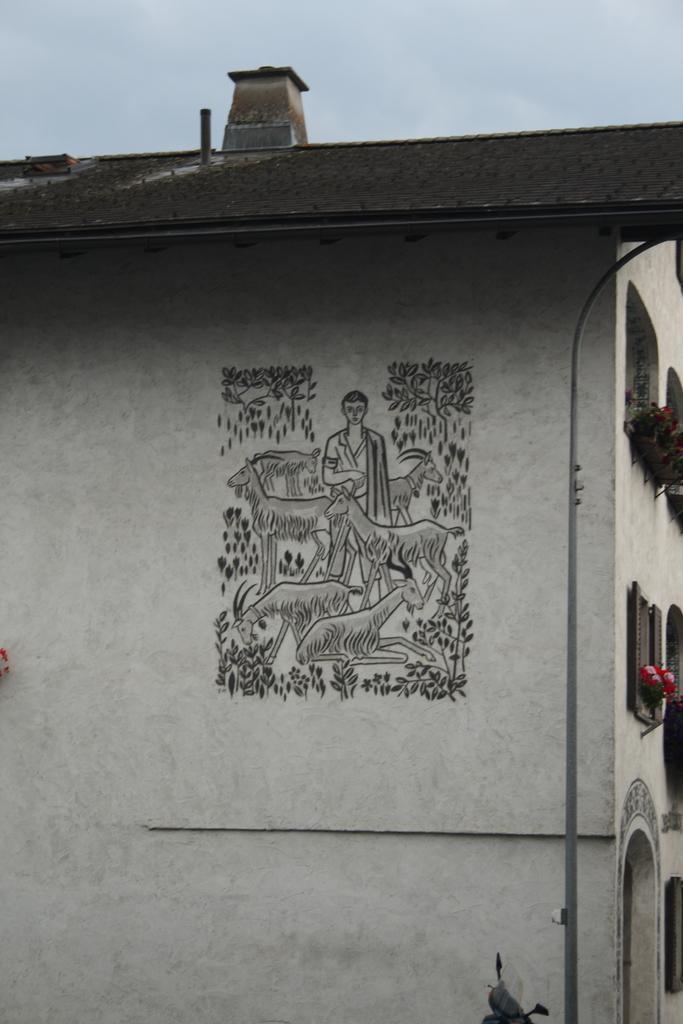Describe this image in one or two sentences. In this picture we can see a building with a design on the wall and some objects and in the background we can see the sky. 